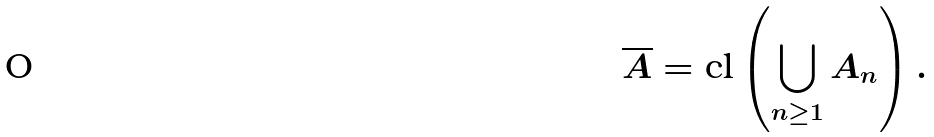<formula> <loc_0><loc_0><loc_500><loc_500>\overline { A } = \text {cl} \left ( \bigcup _ { n \geq 1 } A _ { n } \right ) .</formula> 